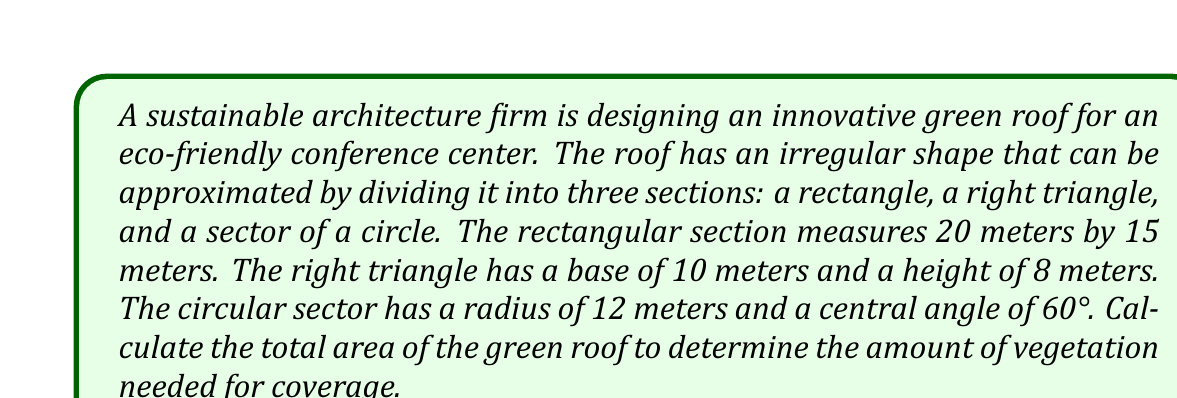Help me with this question. To solve this problem, we need to calculate the area of each section and then sum them up:

1. Area of the rectangle:
   $A_{rectangle} = length \times width = 20 \times 15 = 300$ m²

2. Area of the right triangle:
   $A_{triangle} = \frac{1}{2} \times base \times height = \frac{1}{2} \times 10 \times 8 = 40$ m²

3. Area of the circular sector:
   The formula for the area of a circular sector is:
   $$A_{sector} = \frac{\theta}{360°} \times \pi r^2$$
   where $\theta$ is the central angle in degrees and $r$ is the radius.

   $A_{sector} = \frac{60°}{360°} \times \pi \times 12^2 = \frac{1}{6} \times \pi \times 144 = 24\pi$ m²

Now, we sum up all three areas:

$$A_{total} = A_{rectangle} + A_{triangle} + A_{sector}$$
$$A_{total} = 300 + 40 + 24\pi$$
$$A_{total} = 340 + 24\pi \approx 415.41 \text{ m²}$$
Answer: The total area of the green roof is $340 + 24\pi$ m² or approximately 415.41 m². 